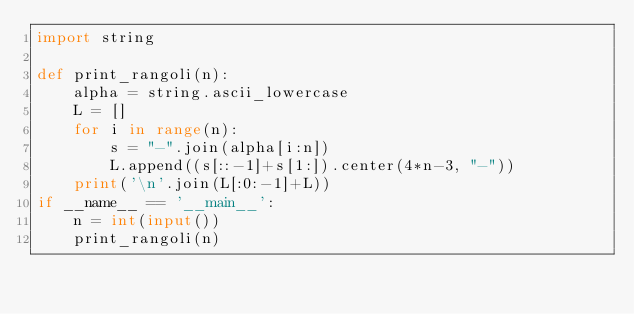Convert code to text. <code><loc_0><loc_0><loc_500><loc_500><_Python_>import string

def print_rangoli(n):
    alpha = string.ascii_lowercase
    L = []
    for i in range(n):
        s = "-".join(alpha[i:n])
        L.append((s[::-1]+s[1:]).center(4*n-3, "-"))
    print('\n'.join(L[:0:-1]+L))
if __name__ == '__main__':
    n = int(input())
    print_rangoli(n)
</code> 